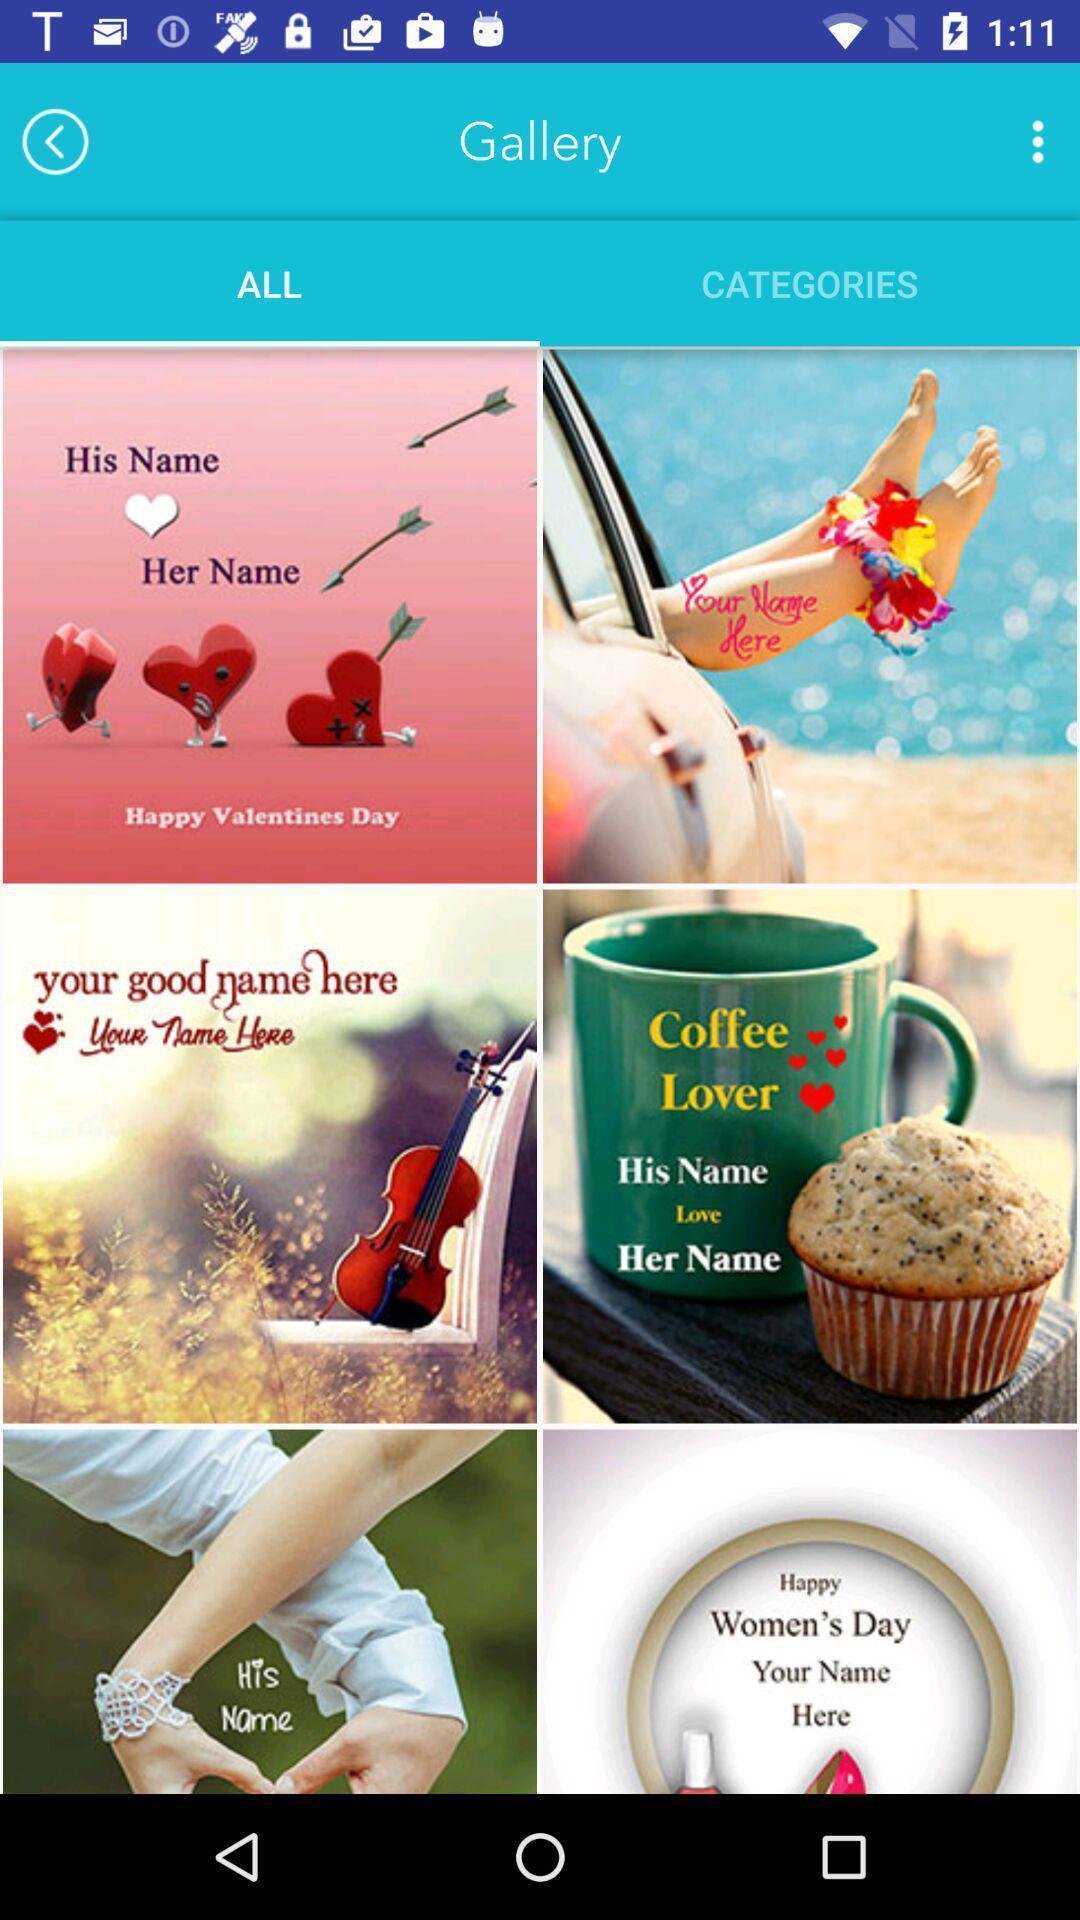Describe the key features of this screenshot. Various images in an gallery. 